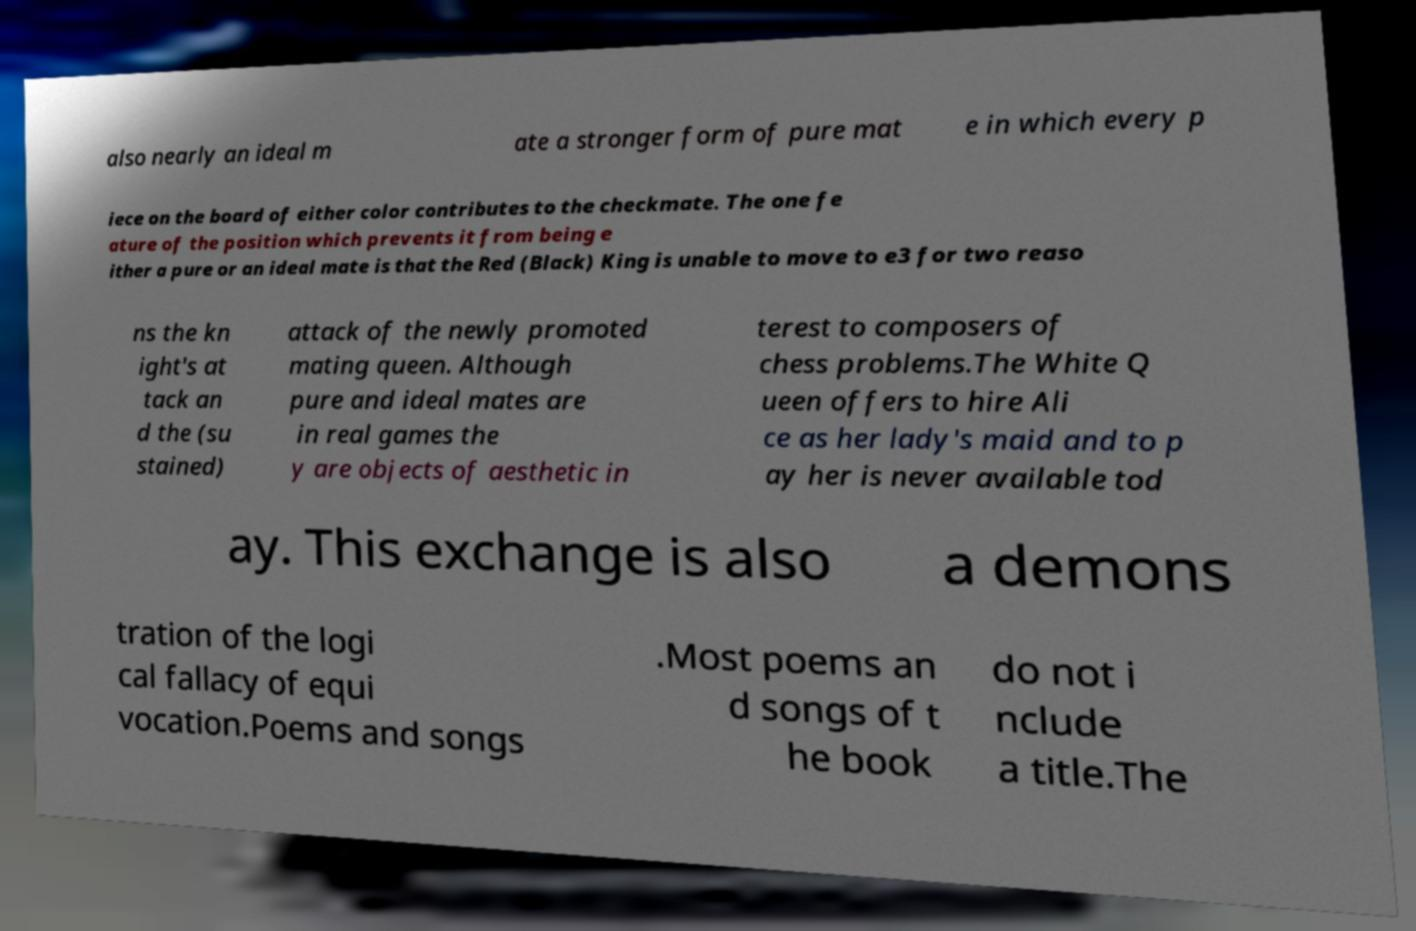What messages or text are displayed in this image? I need them in a readable, typed format. also nearly an ideal m ate a stronger form of pure mat e in which every p iece on the board of either color contributes to the checkmate. The one fe ature of the position which prevents it from being e ither a pure or an ideal mate is that the Red (Black) King is unable to move to e3 for two reaso ns the kn ight's at tack an d the (su stained) attack of the newly promoted mating queen. Although pure and ideal mates are in real games the y are objects of aesthetic in terest to composers of chess problems.The White Q ueen offers to hire Ali ce as her lady's maid and to p ay her is never available tod ay. This exchange is also a demons tration of the logi cal fallacy of equi vocation.Poems and songs .Most poems an d songs of t he book do not i nclude a title.The 